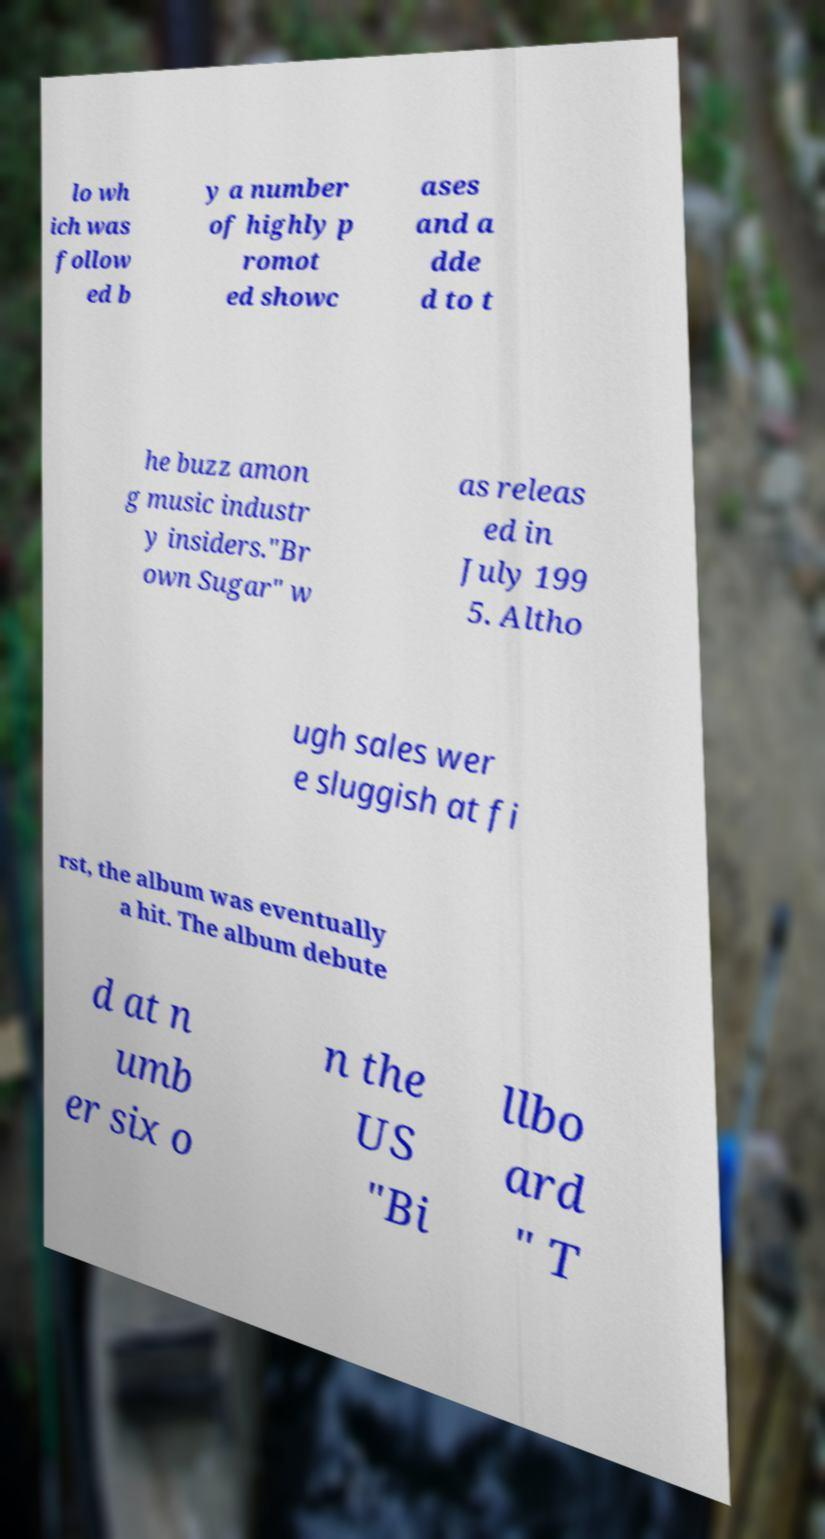Please identify and transcribe the text found in this image. lo wh ich was follow ed b y a number of highly p romot ed showc ases and a dde d to t he buzz amon g music industr y insiders."Br own Sugar" w as releas ed in July 199 5. Altho ugh sales wer e sluggish at fi rst, the album was eventually a hit. The album debute d at n umb er six o n the US "Bi llbo ard " T 